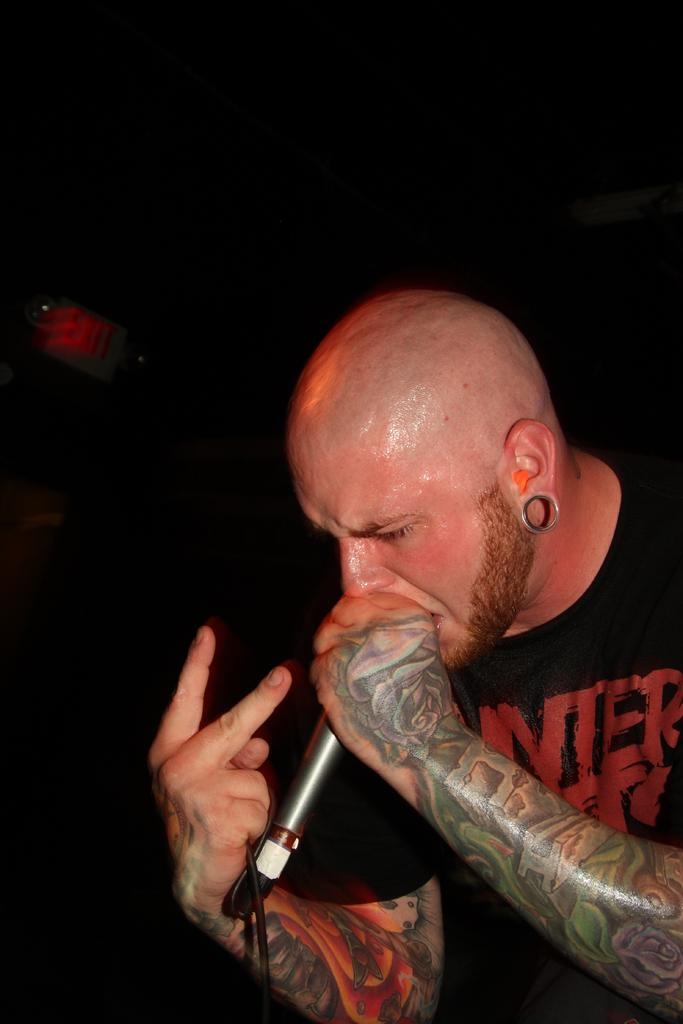Who is the main subject in the image? There is a man in the image. What is the man doing in the image? The man is singing in the image. What tool is the man using while singing? The man is using a microphone in the image. What can be observed about the background of the image? The background of the image is dark. How many noses can be seen on the man in the image? There is only one man in the image, and he has one nose. What force is being applied to the microphone by the man in the image? There is no information about the force being applied to the microphone in the image. 